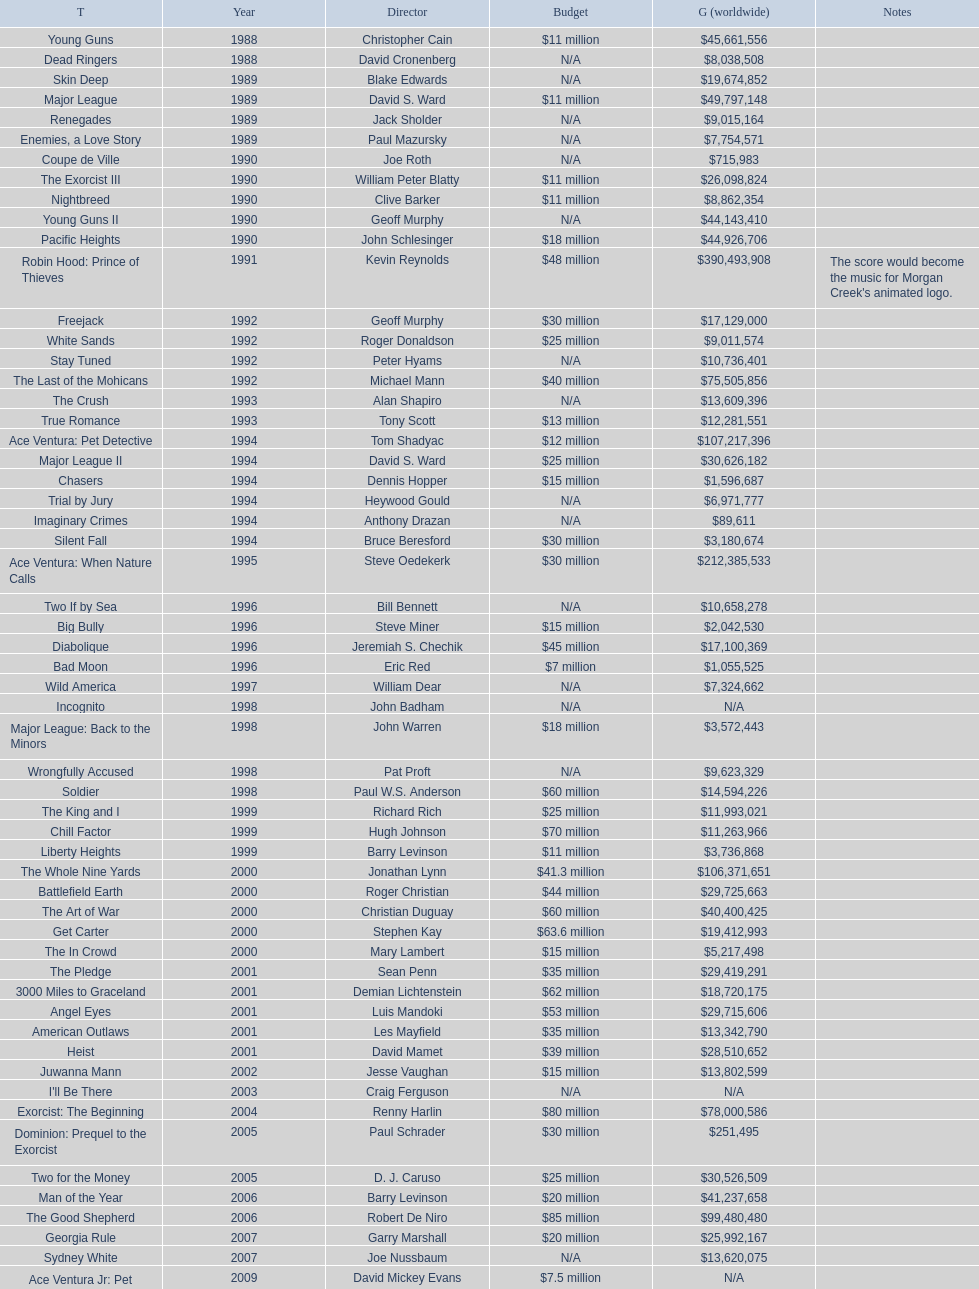Which morgan creek film grossed the most worldwide? Robin Hood: Prince of Thieves. 